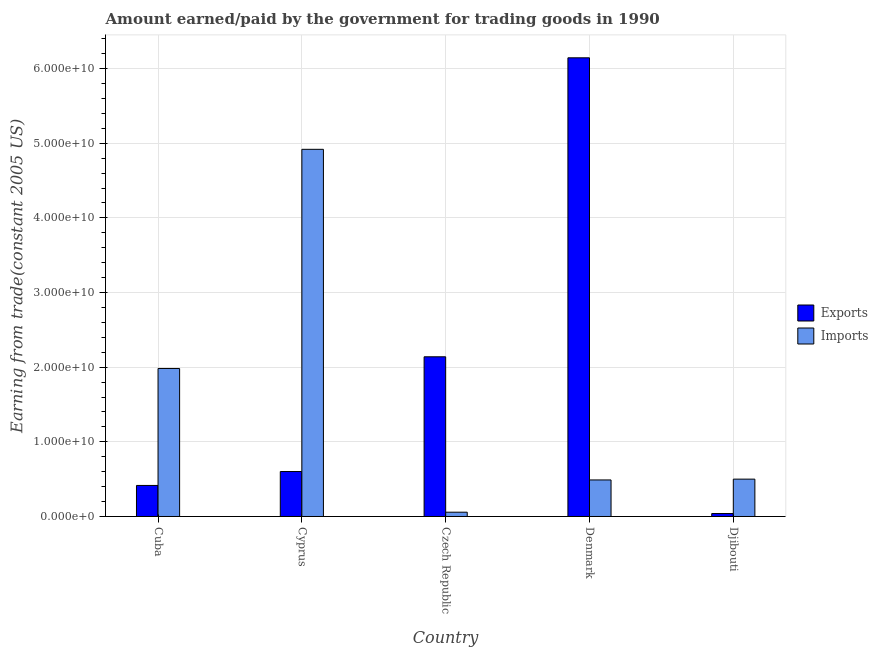How many different coloured bars are there?
Provide a short and direct response. 2. How many groups of bars are there?
Make the answer very short. 5. What is the label of the 5th group of bars from the left?
Your response must be concise. Djibouti. In how many cases, is the number of bars for a given country not equal to the number of legend labels?
Your response must be concise. 0. What is the amount paid for imports in Cyprus?
Give a very brief answer. 4.92e+1. Across all countries, what is the maximum amount paid for imports?
Provide a short and direct response. 4.92e+1. Across all countries, what is the minimum amount paid for imports?
Make the answer very short. 5.75e+08. In which country was the amount paid for imports maximum?
Your answer should be very brief. Cyprus. In which country was the amount paid for imports minimum?
Your response must be concise. Czech Republic. What is the total amount paid for imports in the graph?
Keep it short and to the point. 7.95e+1. What is the difference between the amount earned from exports in Cuba and that in Denmark?
Make the answer very short. -5.73e+1. What is the difference between the amount paid for imports in Denmark and the amount earned from exports in Cyprus?
Offer a very short reply. -1.13e+09. What is the average amount paid for imports per country?
Offer a terse response. 1.59e+1. What is the difference between the amount earned from exports and amount paid for imports in Cyprus?
Give a very brief answer. -4.32e+1. What is the ratio of the amount earned from exports in Czech Republic to that in Djibouti?
Provide a succinct answer. 54.23. Is the amount earned from exports in Cyprus less than that in Denmark?
Keep it short and to the point. Yes. Is the difference between the amount paid for imports in Cuba and Czech Republic greater than the difference between the amount earned from exports in Cuba and Czech Republic?
Give a very brief answer. Yes. What is the difference between the highest and the second highest amount paid for imports?
Offer a terse response. 2.94e+1. What is the difference between the highest and the lowest amount earned from exports?
Make the answer very short. 6.11e+1. In how many countries, is the amount paid for imports greater than the average amount paid for imports taken over all countries?
Offer a terse response. 2. Is the sum of the amount paid for imports in Cyprus and Djibouti greater than the maximum amount earned from exports across all countries?
Keep it short and to the point. No. What does the 2nd bar from the left in Denmark represents?
Your answer should be compact. Imports. What does the 1st bar from the right in Denmark represents?
Give a very brief answer. Imports. How many bars are there?
Offer a very short reply. 10. What is the difference between two consecutive major ticks on the Y-axis?
Make the answer very short. 1.00e+1. Are the values on the major ticks of Y-axis written in scientific E-notation?
Provide a short and direct response. Yes. Where does the legend appear in the graph?
Keep it short and to the point. Center right. How many legend labels are there?
Offer a very short reply. 2. What is the title of the graph?
Your answer should be very brief. Amount earned/paid by the government for trading goods in 1990. What is the label or title of the X-axis?
Your response must be concise. Country. What is the label or title of the Y-axis?
Your response must be concise. Earning from trade(constant 2005 US). What is the Earning from trade(constant 2005 US) of Exports in Cuba?
Your answer should be compact. 4.16e+09. What is the Earning from trade(constant 2005 US) in Imports in Cuba?
Offer a terse response. 1.98e+1. What is the Earning from trade(constant 2005 US) of Exports in Cyprus?
Your answer should be very brief. 6.02e+09. What is the Earning from trade(constant 2005 US) in Imports in Cyprus?
Offer a terse response. 4.92e+1. What is the Earning from trade(constant 2005 US) of Exports in Czech Republic?
Provide a short and direct response. 2.14e+1. What is the Earning from trade(constant 2005 US) of Imports in Czech Republic?
Your response must be concise. 5.75e+08. What is the Earning from trade(constant 2005 US) of Exports in Denmark?
Provide a short and direct response. 6.14e+1. What is the Earning from trade(constant 2005 US) of Imports in Denmark?
Offer a very short reply. 4.90e+09. What is the Earning from trade(constant 2005 US) of Exports in Djibouti?
Provide a short and direct response. 3.94e+08. What is the Earning from trade(constant 2005 US) of Imports in Djibouti?
Your answer should be compact. 5.00e+09. Across all countries, what is the maximum Earning from trade(constant 2005 US) in Exports?
Offer a terse response. 6.14e+1. Across all countries, what is the maximum Earning from trade(constant 2005 US) of Imports?
Your answer should be very brief. 4.92e+1. Across all countries, what is the minimum Earning from trade(constant 2005 US) of Exports?
Make the answer very short. 3.94e+08. Across all countries, what is the minimum Earning from trade(constant 2005 US) of Imports?
Give a very brief answer. 5.75e+08. What is the total Earning from trade(constant 2005 US) of Exports in the graph?
Provide a succinct answer. 9.34e+1. What is the total Earning from trade(constant 2005 US) of Imports in the graph?
Your answer should be very brief. 7.95e+1. What is the difference between the Earning from trade(constant 2005 US) in Exports in Cuba and that in Cyprus?
Provide a short and direct response. -1.86e+09. What is the difference between the Earning from trade(constant 2005 US) of Imports in Cuba and that in Cyprus?
Offer a very short reply. -2.94e+1. What is the difference between the Earning from trade(constant 2005 US) in Exports in Cuba and that in Czech Republic?
Your answer should be compact. -1.72e+1. What is the difference between the Earning from trade(constant 2005 US) of Imports in Cuba and that in Czech Republic?
Your answer should be very brief. 1.93e+1. What is the difference between the Earning from trade(constant 2005 US) of Exports in Cuba and that in Denmark?
Provide a succinct answer. -5.73e+1. What is the difference between the Earning from trade(constant 2005 US) in Imports in Cuba and that in Denmark?
Your response must be concise. 1.49e+1. What is the difference between the Earning from trade(constant 2005 US) in Exports in Cuba and that in Djibouti?
Your answer should be compact. 3.76e+09. What is the difference between the Earning from trade(constant 2005 US) of Imports in Cuba and that in Djibouti?
Offer a very short reply. 1.48e+1. What is the difference between the Earning from trade(constant 2005 US) of Exports in Cyprus and that in Czech Republic?
Give a very brief answer. -1.54e+1. What is the difference between the Earning from trade(constant 2005 US) of Imports in Cyprus and that in Czech Republic?
Keep it short and to the point. 4.86e+1. What is the difference between the Earning from trade(constant 2005 US) of Exports in Cyprus and that in Denmark?
Your response must be concise. -5.54e+1. What is the difference between the Earning from trade(constant 2005 US) in Imports in Cyprus and that in Denmark?
Provide a succinct answer. 4.43e+1. What is the difference between the Earning from trade(constant 2005 US) in Exports in Cyprus and that in Djibouti?
Give a very brief answer. 5.63e+09. What is the difference between the Earning from trade(constant 2005 US) of Imports in Cyprus and that in Djibouti?
Offer a terse response. 4.42e+1. What is the difference between the Earning from trade(constant 2005 US) in Exports in Czech Republic and that in Denmark?
Offer a terse response. -4.01e+1. What is the difference between the Earning from trade(constant 2005 US) in Imports in Czech Republic and that in Denmark?
Your answer should be very brief. -4.32e+09. What is the difference between the Earning from trade(constant 2005 US) of Exports in Czech Republic and that in Djibouti?
Your answer should be very brief. 2.10e+1. What is the difference between the Earning from trade(constant 2005 US) of Imports in Czech Republic and that in Djibouti?
Ensure brevity in your answer.  -4.43e+09. What is the difference between the Earning from trade(constant 2005 US) in Exports in Denmark and that in Djibouti?
Provide a short and direct response. 6.11e+1. What is the difference between the Earning from trade(constant 2005 US) in Imports in Denmark and that in Djibouti?
Provide a short and direct response. -1.07e+08. What is the difference between the Earning from trade(constant 2005 US) in Exports in Cuba and the Earning from trade(constant 2005 US) in Imports in Cyprus?
Give a very brief answer. -4.50e+1. What is the difference between the Earning from trade(constant 2005 US) in Exports in Cuba and the Earning from trade(constant 2005 US) in Imports in Czech Republic?
Your response must be concise. 3.58e+09. What is the difference between the Earning from trade(constant 2005 US) in Exports in Cuba and the Earning from trade(constant 2005 US) in Imports in Denmark?
Provide a short and direct response. -7.37e+08. What is the difference between the Earning from trade(constant 2005 US) in Exports in Cuba and the Earning from trade(constant 2005 US) in Imports in Djibouti?
Your response must be concise. -8.45e+08. What is the difference between the Earning from trade(constant 2005 US) of Exports in Cyprus and the Earning from trade(constant 2005 US) of Imports in Czech Republic?
Your answer should be compact. 5.45e+09. What is the difference between the Earning from trade(constant 2005 US) in Exports in Cyprus and the Earning from trade(constant 2005 US) in Imports in Denmark?
Your response must be concise. 1.13e+09. What is the difference between the Earning from trade(constant 2005 US) of Exports in Cyprus and the Earning from trade(constant 2005 US) of Imports in Djibouti?
Make the answer very short. 1.02e+09. What is the difference between the Earning from trade(constant 2005 US) of Exports in Czech Republic and the Earning from trade(constant 2005 US) of Imports in Denmark?
Make the answer very short. 1.65e+1. What is the difference between the Earning from trade(constant 2005 US) in Exports in Czech Republic and the Earning from trade(constant 2005 US) in Imports in Djibouti?
Ensure brevity in your answer.  1.64e+1. What is the difference between the Earning from trade(constant 2005 US) of Exports in Denmark and the Earning from trade(constant 2005 US) of Imports in Djibouti?
Your response must be concise. 5.64e+1. What is the average Earning from trade(constant 2005 US) of Exports per country?
Your response must be concise. 1.87e+1. What is the average Earning from trade(constant 2005 US) in Imports per country?
Provide a short and direct response. 1.59e+1. What is the difference between the Earning from trade(constant 2005 US) in Exports and Earning from trade(constant 2005 US) in Imports in Cuba?
Offer a very short reply. -1.57e+1. What is the difference between the Earning from trade(constant 2005 US) in Exports and Earning from trade(constant 2005 US) in Imports in Cyprus?
Provide a short and direct response. -4.32e+1. What is the difference between the Earning from trade(constant 2005 US) in Exports and Earning from trade(constant 2005 US) in Imports in Czech Republic?
Provide a short and direct response. 2.08e+1. What is the difference between the Earning from trade(constant 2005 US) of Exports and Earning from trade(constant 2005 US) of Imports in Denmark?
Provide a short and direct response. 5.66e+1. What is the difference between the Earning from trade(constant 2005 US) in Exports and Earning from trade(constant 2005 US) in Imports in Djibouti?
Your response must be concise. -4.61e+09. What is the ratio of the Earning from trade(constant 2005 US) in Exports in Cuba to that in Cyprus?
Your answer should be very brief. 0.69. What is the ratio of the Earning from trade(constant 2005 US) of Imports in Cuba to that in Cyprus?
Make the answer very short. 0.4. What is the ratio of the Earning from trade(constant 2005 US) in Exports in Cuba to that in Czech Republic?
Provide a short and direct response. 0.19. What is the ratio of the Earning from trade(constant 2005 US) in Imports in Cuba to that in Czech Republic?
Offer a terse response. 34.5. What is the ratio of the Earning from trade(constant 2005 US) of Exports in Cuba to that in Denmark?
Offer a very short reply. 0.07. What is the ratio of the Earning from trade(constant 2005 US) of Imports in Cuba to that in Denmark?
Your answer should be very brief. 4.05. What is the ratio of the Earning from trade(constant 2005 US) of Exports in Cuba to that in Djibouti?
Your answer should be compact. 10.54. What is the ratio of the Earning from trade(constant 2005 US) in Imports in Cuba to that in Djibouti?
Your answer should be very brief. 3.96. What is the ratio of the Earning from trade(constant 2005 US) in Exports in Cyprus to that in Czech Republic?
Give a very brief answer. 0.28. What is the ratio of the Earning from trade(constant 2005 US) of Imports in Cyprus to that in Czech Republic?
Keep it short and to the point. 85.59. What is the ratio of the Earning from trade(constant 2005 US) in Exports in Cyprus to that in Denmark?
Your answer should be very brief. 0.1. What is the ratio of the Earning from trade(constant 2005 US) of Imports in Cyprus to that in Denmark?
Make the answer very short. 10.05. What is the ratio of the Earning from trade(constant 2005 US) of Exports in Cyprus to that in Djibouti?
Keep it short and to the point. 15.27. What is the ratio of the Earning from trade(constant 2005 US) of Imports in Cyprus to that in Djibouti?
Your answer should be very brief. 9.83. What is the ratio of the Earning from trade(constant 2005 US) of Exports in Czech Republic to that in Denmark?
Offer a very short reply. 0.35. What is the ratio of the Earning from trade(constant 2005 US) in Imports in Czech Republic to that in Denmark?
Offer a very short reply. 0.12. What is the ratio of the Earning from trade(constant 2005 US) in Exports in Czech Republic to that in Djibouti?
Your response must be concise. 54.23. What is the ratio of the Earning from trade(constant 2005 US) of Imports in Czech Republic to that in Djibouti?
Offer a terse response. 0.11. What is the ratio of the Earning from trade(constant 2005 US) in Exports in Denmark to that in Djibouti?
Your response must be concise. 155.77. What is the ratio of the Earning from trade(constant 2005 US) in Imports in Denmark to that in Djibouti?
Offer a terse response. 0.98. What is the difference between the highest and the second highest Earning from trade(constant 2005 US) in Exports?
Give a very brief answer. 4.01e+1. What is the difference between the highest and the second highest Earning from trade(constant 2005 US) of Imports?
Offer a very short reply. 2.94e+1. What is the difference between the highest and the lowest Earning from trade(constant 2005 US) in Exports?
Offer a terse response. 6.11e+1. What is the difference between the highest and the lowest Earning from trade(constant 2005 US) of Imports?
Keep it short and to the point. 4.86e+1. 